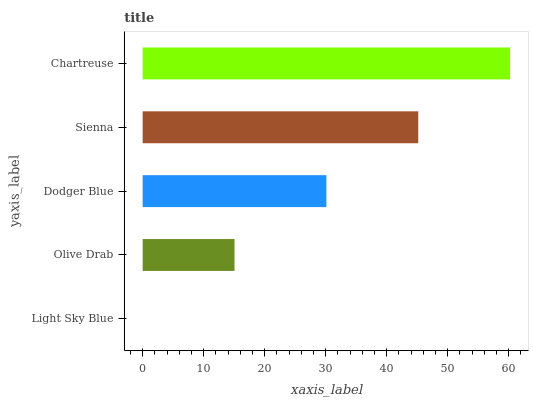Is Light Sky Blue the minimum?
Answer yes or no. Yes. Is Chartreuse the maximum?
Answer yes or no. Yes. Is Olive Drab the minimum?
Answer yes or no. No. Is Olive Drab the maximum?
Answer yes or no. No. Is Olive Drab greater than Light Sky Blue?
Answer yes or no. Yes. Is Light Sky Blue less than Olive Drab?
Answer yes or no. Yes. Is Light Sky Blue greater than Olive Drab?
Answer yes or no. No. Is Olive Drab less than Light Sky Blue?
Answer yes or no. No. Is Dodger Blue the high median?
Answer yes or no. Yes. Is Dodger Blue the low median?
Answer yes or no. Yes. Is Chartreuse the high median?
Answer yes or no. No. Is Light Sky Blue the low median?
Answer yes or no. No. 